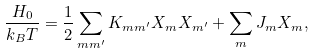<formula> <loc_0><loc_0><loc_500><loc_500>\frac { H _ { 0 } } { k _ { B } T } = \frac { 1 } { 2 } \sum _ { m m ^ { \prime } } K _ { m m ^ { \prime } } { X } _ { m } { X } _ { m ^ { \prime } } + \sum _ { m } { J } _ { m } { X } _ { m } ,</formula> 